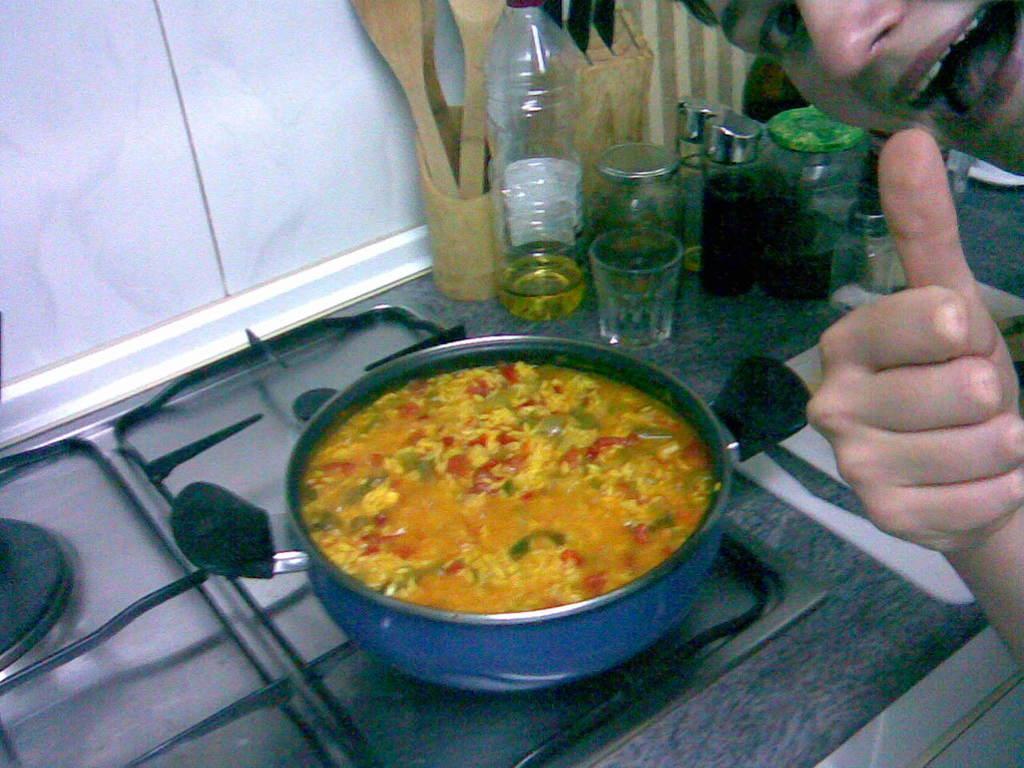Please provide a concise description of this image. This is a kitchen platform. We can see glasses, oil bottle, containers and a chopping board on the platform. This is a stove. We can see a curry in a vessel. We can see a person showing thumb. 